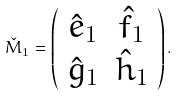<formula> <loc_0><loc_0><loc_500><loc_500>\check { M } _ { 1 } = \left ( \begin{array} { c c } \hat { e } _ { 1 } & \hat { f } _ { 1 } \\ \hat { g } _ { 1 } & \hat { h } _ { 1 } \end{array} \right ) .</formula> 